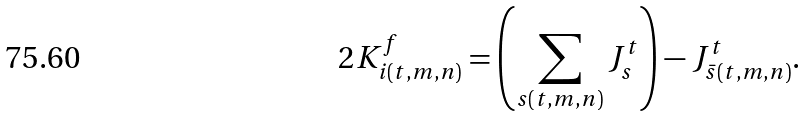Convert formula to latex. <formula><loc_0><loc_0><loc_500><loc_500>2 K _ { i ( t , m , n ) } ^ { f } = \left ( \sum _ { s ( t , m , n ) } J _ { s } ^ { t } \right ) - J _ { \bar { s } ( t , m , n ) } ^ { t } .</formula> 